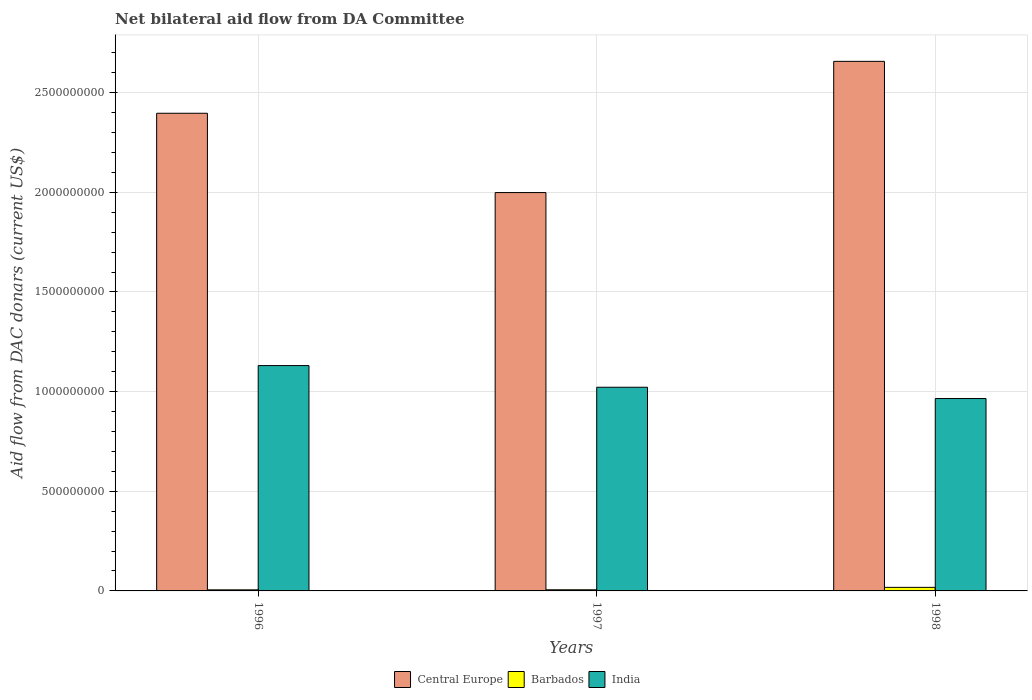How many different coloured bars are there?
Your response must be concise. 3. Are the number of bars per tick equal to the number of legend labels?
Offer a terse response. Yes. What is the label of the 3rd group of bars from the left?
Offer a very short reply. 1998. What is the aid flow in in Central Europe in 1997?
Your response must be concise. 2.00e+09. Across all years, what is the maximum aid flow in in India?
Your answer should be very brief. 1.13e+09. Across all years, what is the minimum aid flow in in Central Europe?
Offer a terse response. 2.00e+09. In which year was the aid flow in in Central Europe maximum?
Offer a terse response. 1998. In which year was the aid flow in in Barbados minimum?
Provide a succinct answer. 1996. What is the total aid flow in in India in the graph?
Ensure brevity in your answer.  3.12e+09. What is the difference between the aid flow in in India in 1996 and that in 1997?
Offer a very short reply. 1.09e+08. What is the difference between the aid flow in in Central Europe in 1998 and the aid flow in in Barbados in 1996?
Offer a terse response. 2.65e+09. What is the average aid flow in in Central Europe per year?
Your response must be concise. 2.35e+09. In the year 1996, what is the difference between the aid flow in in Central Europe and aid flow in in Barbados?
Offer a terse response. 2.39e+09. In how many years, is the aid flow in in Central Europe greater than 2600000000 US$?
Your answer should be compact. 1. What is the ratio of the aid flow in in Central Europe in 1996 to that in 1998?
Ensure brevity in your answer.  0.9. Is the aid flow in in India in 1996 less than that in 1997?
Your answer should be compact. No. What is the difference between the highest and the second highest aid flow in in Central Europe?
Your response must be concise. 2.60e+08. What is the difference between the highest and the lowest aid flow in in Barbados?
Offer a terse response. 1.24e+07. Is the sum of the aid flow in in India in 1996 and 1997 greater than the maximum aid flow in in Barbados across all years?
Offer a very short reply. Yes. What does the 1st bar from the left in 1996 represents?
Your answer should be very brief. Central Europe. What does the 3rd bar from the right in 1998 represents?
Your answer should be very brief. Central Europe. Is it the case that in every year, the sum of the aid flow in in Central Europe and aid flow in in Barbados is greater than the aid flow in in India?
Provide a succinct answer. Yes. How many bars are there?
Your answer should be very brief. 9. How many years are there in the graph?
Provide a succinct answer. 3. Does the graph contain any zero values?
Offer a terse response. No. Does the graph contain grids?
Your answer should be very brief. Yes. How are the legend labels stacked?
Offer a terse response. Horizontal. What is the title of the graph?
Ensure brevity in your answer.  Net bilateral aid flow from DA Committee. Does "Netherlands" appear as one of the legend labels in the graph?
Your answer should be very brief. No. What is the label or title of the X-axis?
Provide a short and direct response. Years. What is the label or title of the Y-axis?
Give a very brief answer. Aid flow from DAC donars (current US$). What is the Aid flow from DAC donars (current US$) in Central Europe in 1996?
Your answer should be compact. 2.40e+09. What is the Aid flow from DAC donars (current US$) in Barbados in 1996?
Make the answer very short. 5.48e+06. What is the Aid flow from DAC donars (current US$) in India in 1996?
Offer a terse response. 1.13e+09. What is the Aid flow from DAC donars (current US$) of Central Europe in 1997?
Make the answer very short. 2.00e+09. What is the Aid flow from DAC donars (current US$) of Barbados in 1997?
Your answer should be compact. 5.78e+06. What is the Aid flow from DAC donars (current US$) of India in 1997?
Offer a very short reply. 1.02e+09. What is the Aid flow from DAC donars (current US$) of Central Europe in 1998?
Ensure brevity in your answer.  2.66e+09. What is the Aid flow from DAC donars (current US$) in Barbados in 1998?
Your answer should be very brief. 1.78e+07. What is the Aid flow from DAC donars (current US$) in India in 1998?
Provide a short and direct response. 9.65e+08. Across all years, what is the maximum Aid flow from DAC donars (current US$) of Central Europe?
Keep it short and to the point. 2.66e+09. Across all years, what is the maximum Aid flow from DAC donars (current US$) of Barbados?
Make the answer very short. 1.78e+07. Across all years, what is the maximum Aid flow from DAC donars (current US$) of India?
Offer a terse response. 1.13e+09. Across all years, what is the minimum Aid flow from DAC donars (current US$) in Central Europe?
Give a very brief answer. 2.00e+09. Across all years, what is the minimum Aid flow from DAC donars (current US$) in Barbados?
Provide a succinct answer. 5.48e+06. Across all years, what is the minimum Aid flow from DAC donars (current US$) of India?
Ensure brevity in your answer.  9.65e+08. What is the total Aid flow from DAC donars (current US$) of Central Europe in the graph?
Your response must be concise. 7.05e+09. What is the total Aid flow from DAC donars (current US$) in Barbados in the graph?
Offer a very short reply. 2.91e+07. What is the total Aid flow from DAC donars (current US$) in India in the graph?
Make the answer very short. 3.12e+09. What is the difference between the Aid flow from DAC donars (current US$) in Central Europe in 1996 and that in 1997?
Keep it short and to the point. 3.98e+08. What is the difference between the Aid flow from DAC donars (current US$) in Barbados in 1996 and that in 1997?
Keep it short and to the point. -3.00e+05. What is the difference between the Aid flow from DAC donars (current US$) in India in 1996 and that in 1997?
Ensure brevity in your answer.  1.09e+08. What is the difference between the Aid flow from DAC donars (current US$) of Central Europe in 1996 and that in 1998?
Keep it short and to the point. -2.60e+08. What is the difference between the Aid flow from DAC donars (current US$) in Barbados in 1996 and that in 1998?
Provide a short and direct response. -1.24e+07. What is the difference between the Aid flow from DAC donars (current US$) in India in 1996 and that in 1998?
Your answer should be compact. 1.65e+08. What is the difference between the Aid flow from DAC donars (current US$) of Central Europe in 1997 and that in 1998?
Keep it short and to the point. -6.58e+08. What is the difference between the Aid flow from DAC donars (current US$) in Barbados in 1997 and that in 1998?
Ensure brevity in your answer.  -1.21e+07. What is the difference between the Aid flow from DAC donars (current US$) of India in 1997 and that in 1998?
Keep it short and to the point. 5.66e+07. What is the difference between the Aid flow from DAC donars (current US$) of Central Europe in 1996 and the Aid flow from DAC donars (current US$) of Barbados in 1997?
Make the answer very short. 2.39e+09. What is the difference between the Aid flow from DAC donars (current US$) in Central Europe in 1996 and the Aid flow from DAC donars (current US$) in India in 1997?
Provide a succinct answer. 1.37e+09. What is the difference between the Aid flow from DAC donars (current US$) in Barbados in 1996 and the Aid flow from DAC donars (current US$) in India in 1997?
Offer a terse response. -1.02e+09. What is the difference between the Aid flow from DAC donars (current US$) of Central Europe in 1996 and the Aid flow from DAC donars (current US$) of Barbados in 1998?
Ensure brevity in your answer.  2.38e+09. What is the difference between the Aid flow from DAC donars (current US$) of Central Europe in 1996 and the Aid flow from DAC donars (current US$) of India in 1998?
Your answer should be compact. 1.43e+09. What is the difference between the Aid flow from DAC donars (current US$) of Barbados in 1996 and the Aid flow from DAC donars (current US$) of India in 1998?
Offer a very short reply. -9.60e+08. What is the difference between the Aid flow from DAC donars (current US$) of Central Europe in 1997 and the Aid flow from DAC donars (current US$) of Barbados in 1998?
Keep it short and to the point. 1.98e+09. What is the difference between the Aid flow from DAC donars (current US$) in Central Europe in 1997 and the Aid flow from DAC donars (current US$) in India in 1998?
Offer a very short reply. 1.03e+09. What is the difference between the Aid flow from DAC donars (current US$) of Barbados in 1997 and the Aid flow from DAC donars (current US$) of India in 1998?
Offer a very short reply. -9.60e+08. What is the average Aid flow from DAC donars (current US$) in Central Europe per year?
Give a very brief answer. 2.35e+09. What is the average Aid flow from DAC donars (current US$) of Barbados per year?
Give a very brief answer. 9.70e+06. What is the average Aid flow from DAC donars (current US$) in India per year?
Provide a short and direct response. 1.04e+09. In the year 1996, what is the difference between the Aid flow from DAC donars (current US$) of Central Europe and Aid flow from DAC donars (current US$) of Barbados?
Your response must be concise. 2.39e+09. In the year 1996, what is the difference between the Aid flow from DAC donars (current US$) in Central Europe and Aid flow from DAC donars (current US$) in India?
Make the answer very short. 1.27e+09. In the year 1996, what is the difference between the Aid flow from DAC donars (current US$) in Barbados and Aid flow from DAC donars (current US$) in India?
Ensure brevity in your answer.  -1.13e+09. In the year 1997, what is the difference between the Aid flow from DAC donars (current US$) of Central Europe and Aid flow from DAC donars (current US$) of Barbados?
Offer a very short reply. 1.99e+09. In the year 1997, what is the difference between the Aid flow from DAC donars (current US$) in Central Europe and Aid flow from DAC donars (current US$) in India?
Give a very brief answer. 9.77e+08. In the year 1997, what is the difference between the Aid flow from DAC donars (current US$) in Barbados and Aid flow from DAC donars (current US$) in India?
Ensure brevity in your answer.  -1.02e+09. In the year 1998, what is the difference between the Aid flow from DAC donars (current US$) in Central Europe and Aid flow from DAC donars (current US$) in Barbados?
Provide a succinct answer. 2.64e+09. In the year 1998, what is the difference between the Aid flow from DAC donars (current US$) in Central Europe and Aid flow from DAC donars (current US$) in India?
Offer a terse response. 1.69e+09. In the year 1998, what is the difference between the Aid flow from DAC donars (current US$) in Barbados and Aid flow from DAC donars (current US$) in India?
Your answer should be very brief. -9.47e+08. What is the ratio of the Aid flow from DAC donars (current US$) in Central Europe in 1996 to that in 1997?
Provide a succinct answer. 1.2. What is the ratio of the Aid flow from DAC donars (current US$) of Barbados in 1996 to that in 1997?
Ensure brevity in your answer.  0.95. What is the ratio of the Aid flow from DAC donars (current US$) in India in 1996 to that in 1997?
Offer a terse response. 1.11. What is the ratio of the Aid flow from DAC donars (current US$) in Central Europe in 1996 to that in 1998?
Keep it short and to the point. 0.9. What is the ratio of the Aid flow from DAC donars (current US$) of Barbados in 1996 to that in 1998?
Provide a short and direct response. 0.31. What is the ratio of the Aid flow from DAC donars (current US$) in India in 1996 to that in 1998?
Make the answer very short. 1.17. What is the ratio of the Aid flow from DAC donars (current US$) in Central Europe in 1997 to that in 1998?
Offer a very short reply. 0.75. What is the ratio of the Aid flow from DAC donars (current US$) in Barbados in 1997 to that in 1998?
Make the answer very short. 0.32. What is the ratio of the Aid flow from DAC donars (current US$) of India in 1997 to that in 1998?
Keep it short and to the point. 1.06. What is the difference between the highest and the second highest Aid flow from DAC donars (current US$) in Central Europe?
Make the answer very short. 2.60e+08. What is the difference between the highest and the second highest Aid flow from DAC donars (current US$) of Barbados?
Provide a succinct answer. 1.21e+07. What is the difference between the highest and the second highest Aid flow from DAC donars (current US$) of India?
Provide a succinct answer. 1.09e+08. What is the difference between the highest and the lowest Aid flow from DAC donars (current US$) of Central Europe?
Offer a terse response. 6.58e+08. What is the difference between the highest and the lowest Aid flow from DAC donars (current US$) of Barbados?
Provide a succinct answer. 1.24e+07. What is the difference between the highest and the lowest Aid flow from DAC donars (current US$) of India?
Provide a short and direct response. 1.65e+08. 